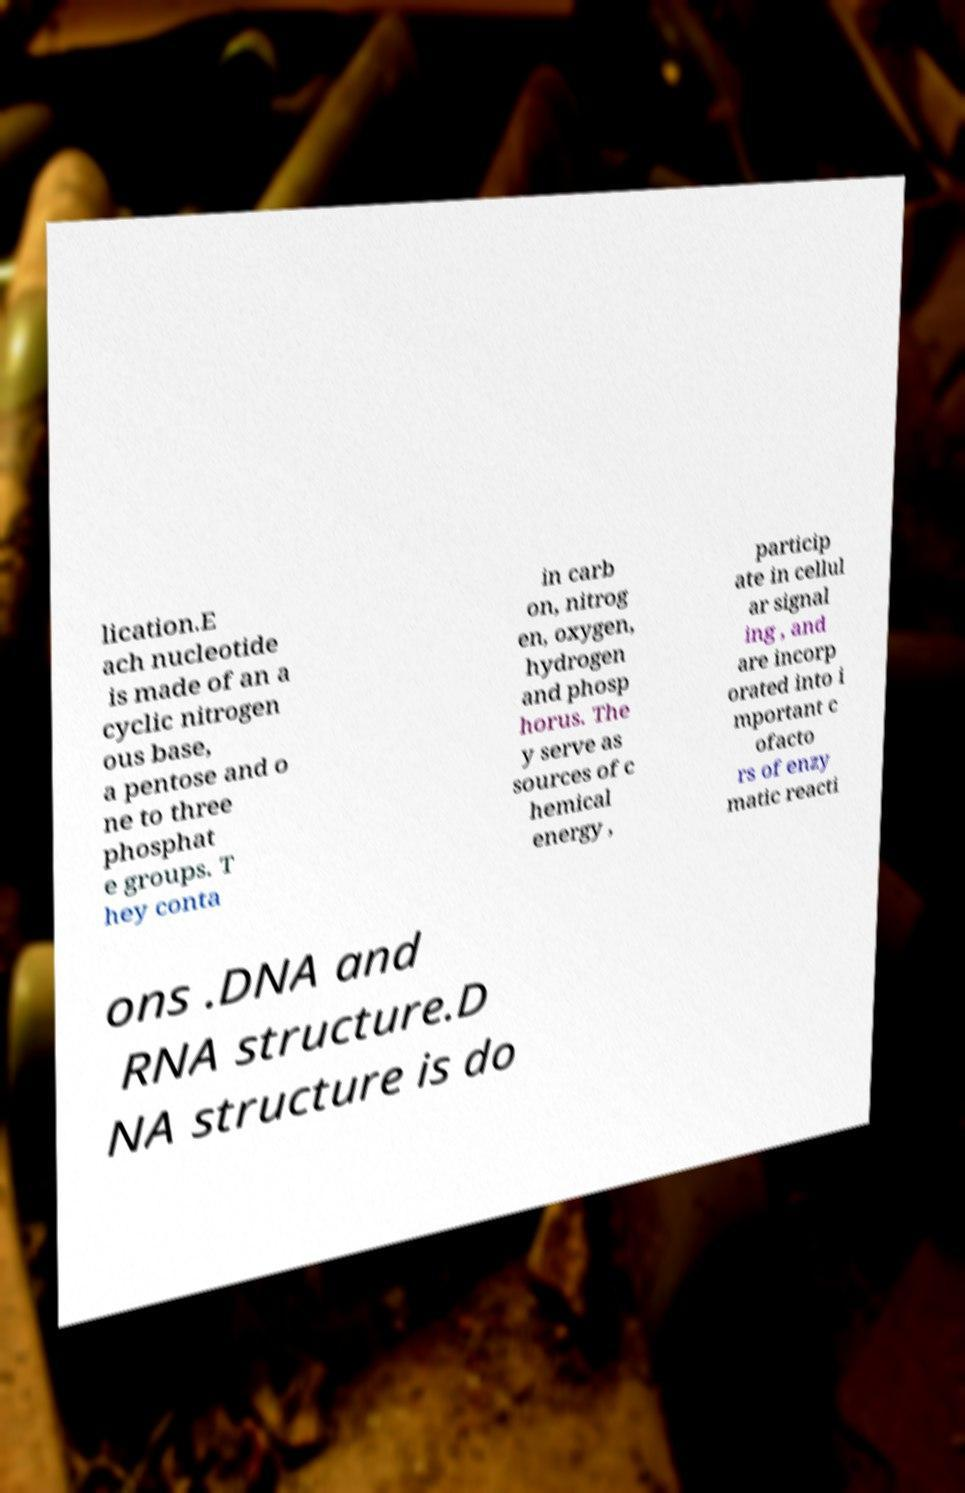For documentation purposes, I need the text within this image transcribed. Could you provide that? lication.E ach nucleotide is made of an a cyclic nitrogen ous base, a pentose and o ne to three phosphat e groups. T hey conta in carb on, nitrog en, oxygen, hydrogen and phosp horus. The y serve as sources of c hemical energy , particip ate in cellul ar signal ing , and are incorp orated into i mportant c ofacto rs of enzy matic reacti ons .DNA and RNA structure.D NA structure is do 